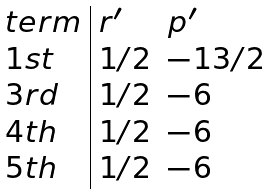Convert formula to latex. <formula><loc_0><loc_0><loc_500><loc_500>\begin{array} { l | l l } t e r m & r ^ { \prime } & p ^ { \prime } \\ 1 s t & 1 / 2 & - 1 3 / 2 \\ 3 r d & 1 / 2 & - 6 \\ 4 t h & 1 / 2 & - 6 \\ 5 t h & 1 / 2 & - 6 \end{array}</formula> 